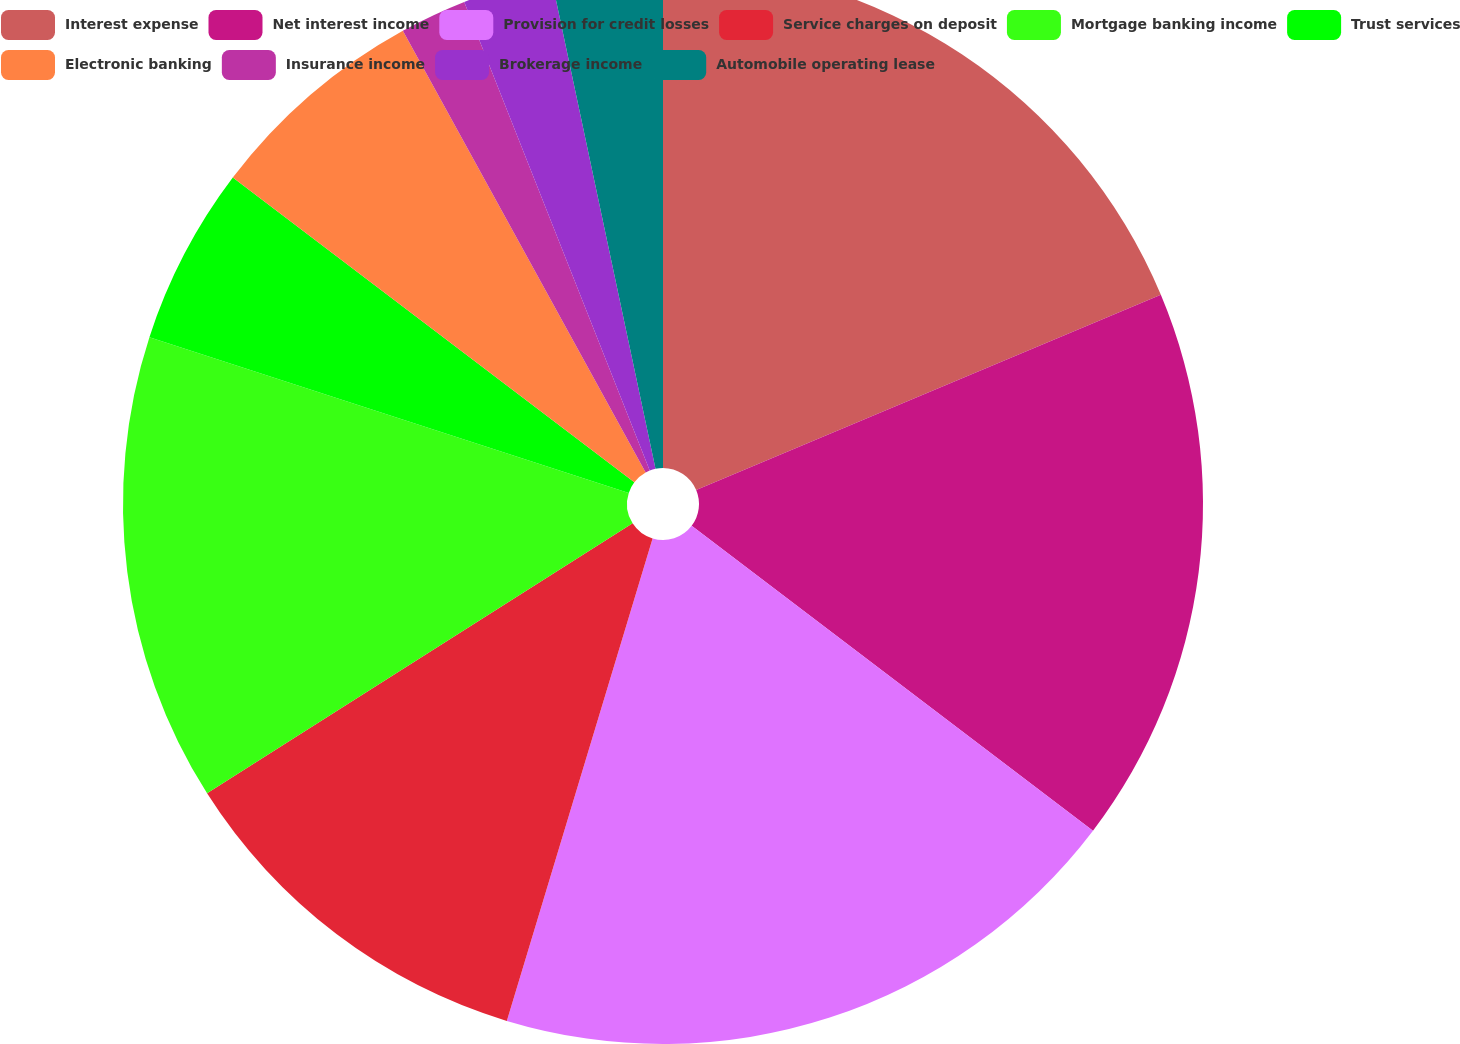Convert chart. <chart><loc_0><loc_0><loc_500><loc_500><pie_chart><fcel>Interest expense<fcel>Net interest income<fcel>Provision for credit losses<fcel>Service charges on deposit<fcel>Mortgage banking income<fcel>Trust services<fcel>Electronic banking<fcel>Insurance income<fcel>Brokerage income<fcel>Automobile operating lease<nl><fcel>18.67%<fcel>16.67%<fcel>19.33%<fcel>11.33%<fcel>14.0%<fcel>5.33%<fcel>6.67%<fcel>2.0%<fcel>2.67%<fcel>3.33%<nl></chart> 